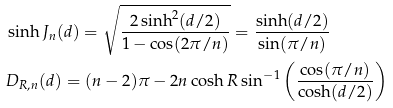Convert formula to latex. <formula><loc_0><loc_0><loc_500><loc_500>& \sinh J _ { n } ( d ) = \sqrt { \frac { 2 \sinh ^ { 2 } ( d / 2 ) } { 1 - \cos ( 2 \pi / n ) } } = \frac { \sinh ( d / 2 ) } { \sin ( \pi / n ) } \\ & D _ { R , n } ( d ) = ( n - 2 ) \pi - 2 n \cosh R \sin ^ { - 1 } \left ( \frac { \cos ( \pi / n ) } { \cosh ( d / 2 ) } \right )</formula> 